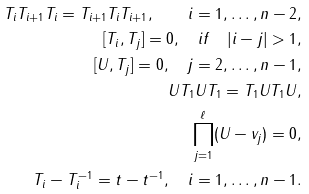<formula> <loc_0><loc_0><loc_500><loc_500>T _ { i } T _ { i + 1 } T _ { i } = T _ { i + 1 } T _ { i } T _ { i + 1 } , \quad i = 1 , \dots , n - 2 , \\ [ T _ { i } , T _ { j } ] = 0 , \quad i f \quad | i - j | > 1 , \\ [ U , T _ { j } ] = 0 , \quad j = 2 , \dots , n - 1 , \\ U T _ { 1 } U T _ { 1 } = T _ { 1 } U T _ { 1 } U , \\ \prod _ { j = 1 } ^ { \ell } ( U - v _ { j } ) = 0 , \\ T _ { i } - T _ { i } ^ { - 1 } = t - t ^ { - 1 } , \quad i = 1 , \dots , n - 1 .</formula> 